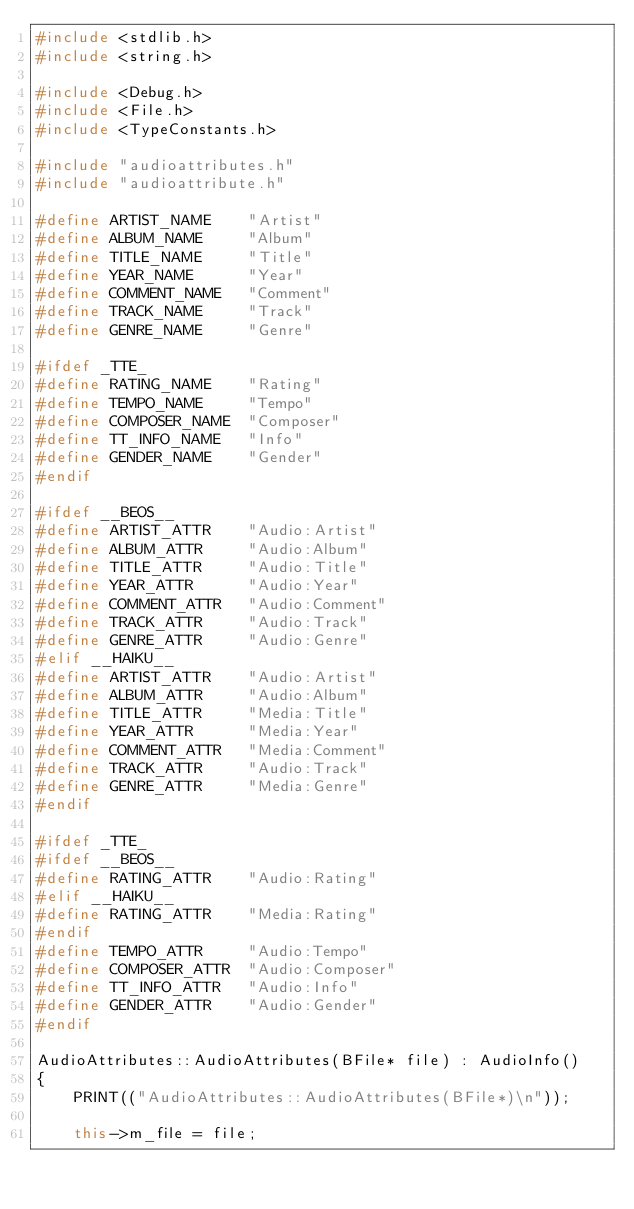<code> <loc_0><loc_0><loc_500><loc_500><_C++_>#include <stdlib.h>
#include <string.h>

#include <Debug.h>
#include <File.h>
#include <TypeConstants.h>

#include "audioattributes.h"
#include "audioattribute.h"

#define ARTIST_NAME    "Artist"
#define ALBUM_NAME     "Album"
#define TITLE_NAME     "Title"
#define YEAR_NAME      "Year"
#define COMMENT_NAME   "Comment"
#define TRACK_NAME     "Track"
#define GENRE_NAME     "Genre"

#ifdef _TTE_
#define RATING_NAME    "Rating"
#define TEMPO_NAME     "Tempo"
#define COMPOSER_NAME  "Composer"
#define TT_INFO_NAME   "Info"
#define GENDER_NAME    "Gender"
#endif

#ifdef __BEOS__
#define ARTIST_ATTR    "Audio:Artist"
#define ALBUM_ATTR     "Audio:Album"
#define TITLE_ATTR     "Audio:Title"
#define YEAR_ATTR      "Audio:Year"
#define COMMENT_ATTR   "Audio:Comment"
#define TRACK_ATTR     "Audio:Track"
#define GENRE_ATTR     "Audio:Genre"
#elif __HAIKU__
#define ARTIST_ATTR    "Audio:Artist"
#define ALBUM_ATTR     "Audio:Album"
#define TITLE_ATTR     "Media:Title"
#define YEAR_ATTR      "Media:Year"
#define COMMENT_ATTR   "Media:Comment"
#define TRACK_ATTR     "Audio:Track"
#define GENRE_ATTR     "Media:Genre"
#endif

#ifdef _TTE_
#ifdef __BEOS__
#define RATING_ATTR    "Audio:Rating"
#elif __HAIKU__
#define RATING_ATTR    "Media:Rating"
#endif
#define TEMPO_ATTR     "Audio:Tempo"
#define COMPOSER_ATTR  "Audio:Composer"
#define TT_INFO_ATTR   "Audio:Info"
#define GENDER_ATTR    "Audio:Gender"
#endif

AudioAttributes::AudioAttributes(BFile* file) : AudioInfo()
{
	PRINT(("AudioAttributes::AudioAttributes(BFile*)\n"));

	this->m_file = file;</code> 